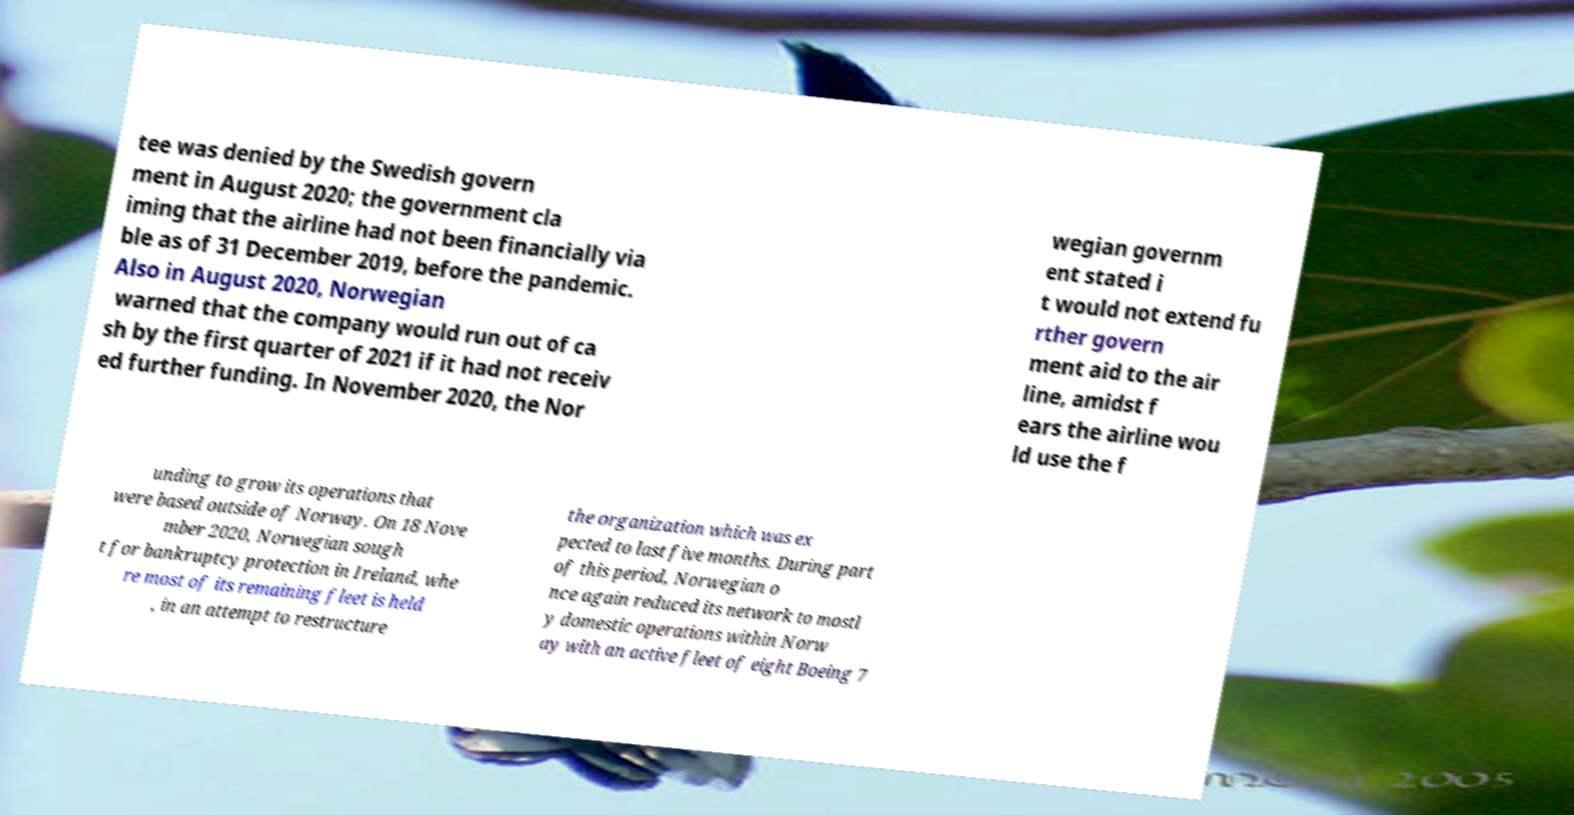I need the written content from this picture converted into text. Can you do that? tee was denied by the Swedish govern ment in August 2020; the government cla iming that the airline had not been financially via ble as of 31 December 2019, before the pandemic. Also in August 2020, Norwegian warned that the company would run out of ca sh by the first quarter of 2021 if it had not receiv ed further funding. In November 2020, the Nor wegian governm ent stated i t would not extend fu rther govern ment aid to the air line, amidst f ears the airline wou ld use the f unding to grow its operations that were based outside of Norway. On 18 Nove mber 2020, Norwegian sough t for bankruptcy protection in Ireland, whe re most of its remaining fleet is held , in an attempt to restructure the organization which was ex pected to last five months. During part of this period, Norwegian o nce again reduced its network to mostl y domestic operations within Norw ay with an active fleet of eight Boeing 7 